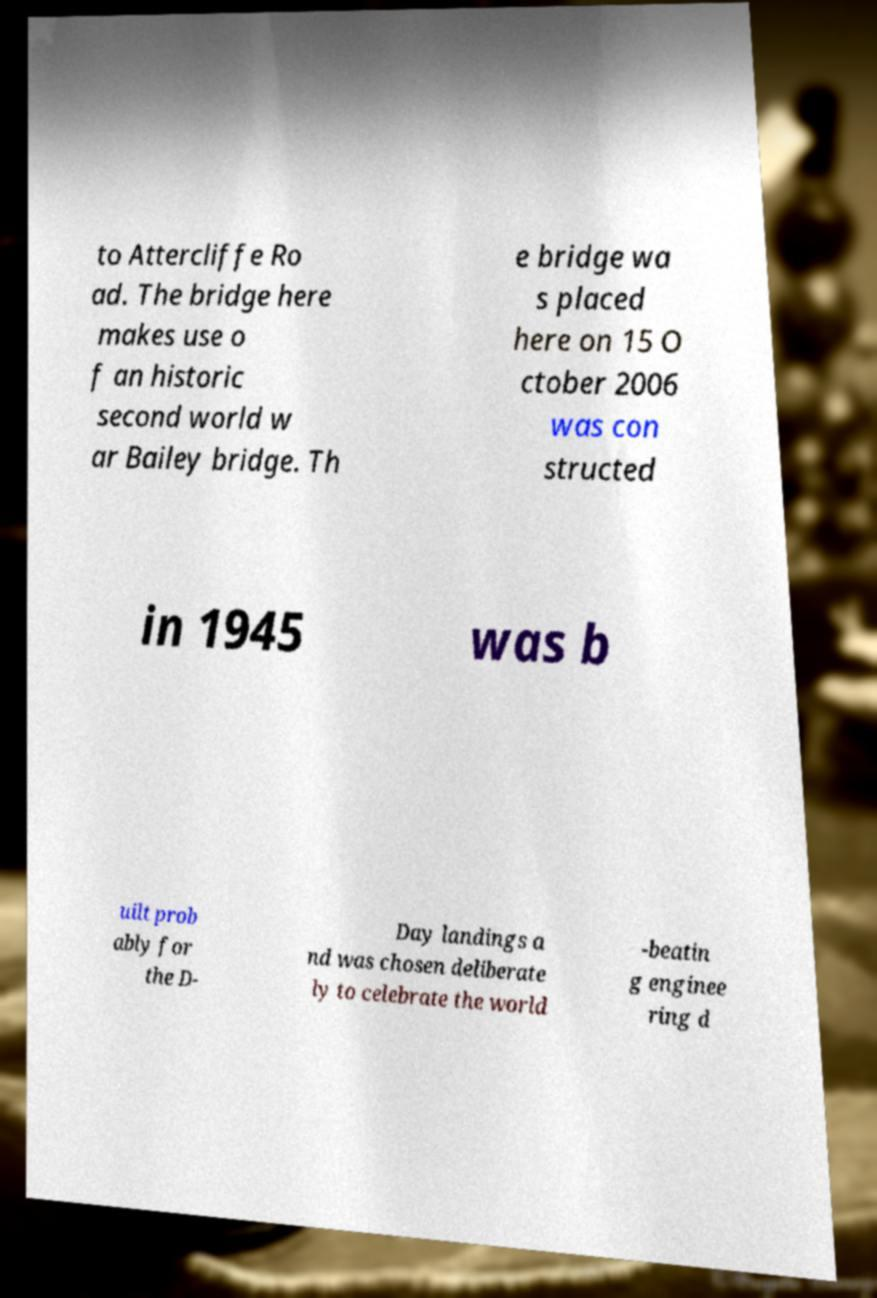Can you accurately transcribe the text from the provided image for me? to Attercliffe Ro ad. The bridge here makes use o f an historic second world w ar Bailey bridge. Th e bridge wa s placed here on 15 O ctober 2006 was con structed in 1945 was b uilt prob ably for the D- Day landings a nd was chosen deliberate ly to celebrate the world -beatin g enginee ring d 